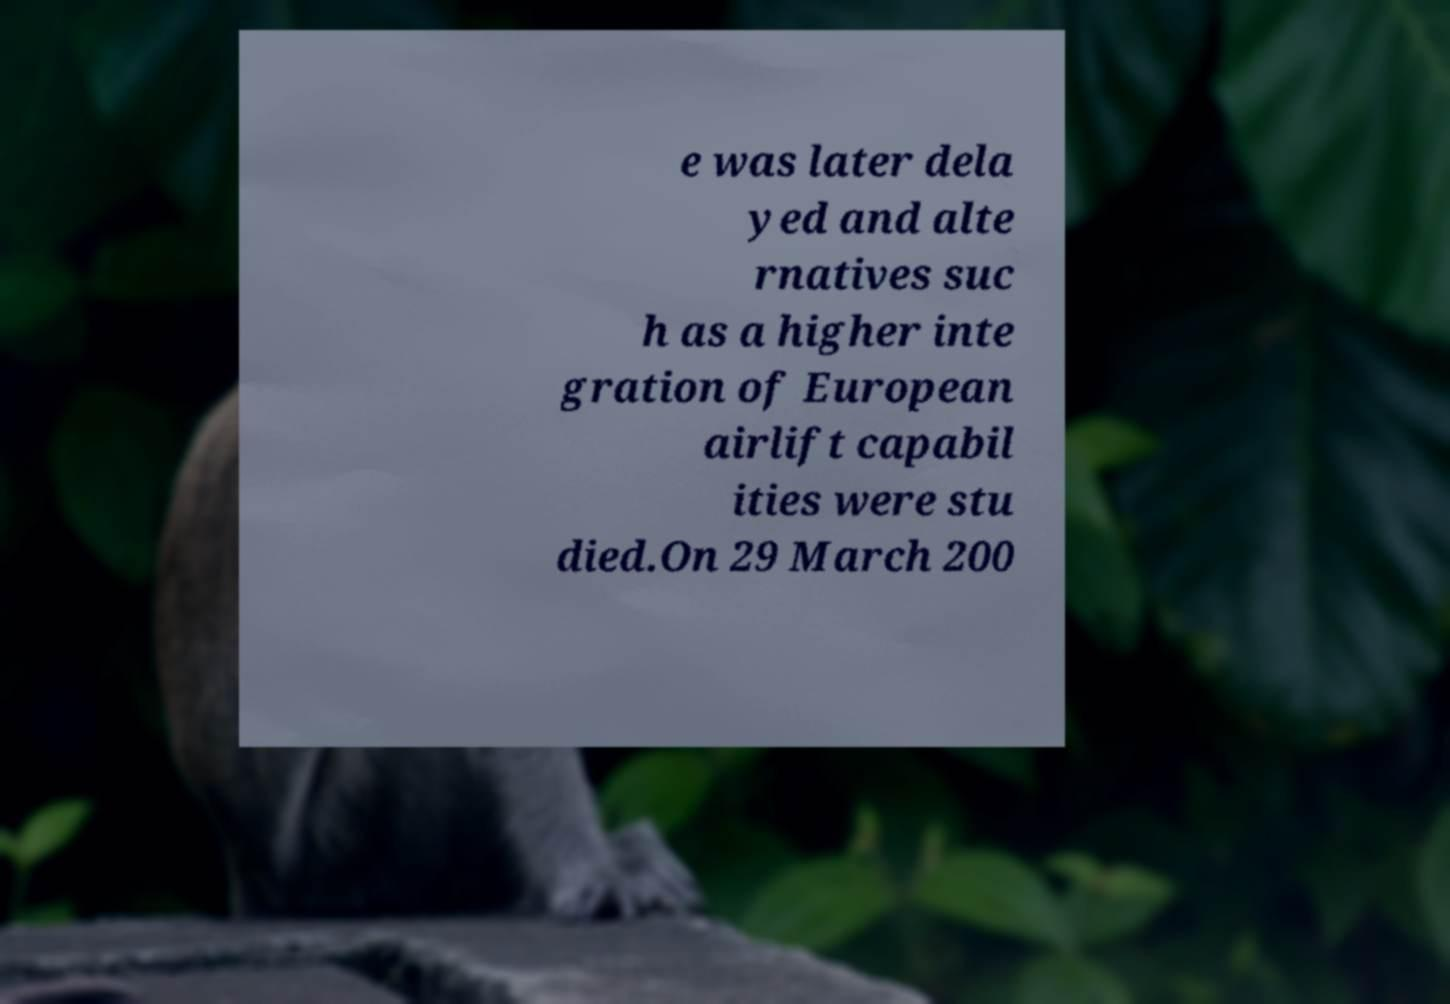I need the written content from this picture converted into text. Can you do that? e was later dela yed and alte rnatives suc h as a higher inte gration of European airlift capabil ities were stu died.On 29 March 200 